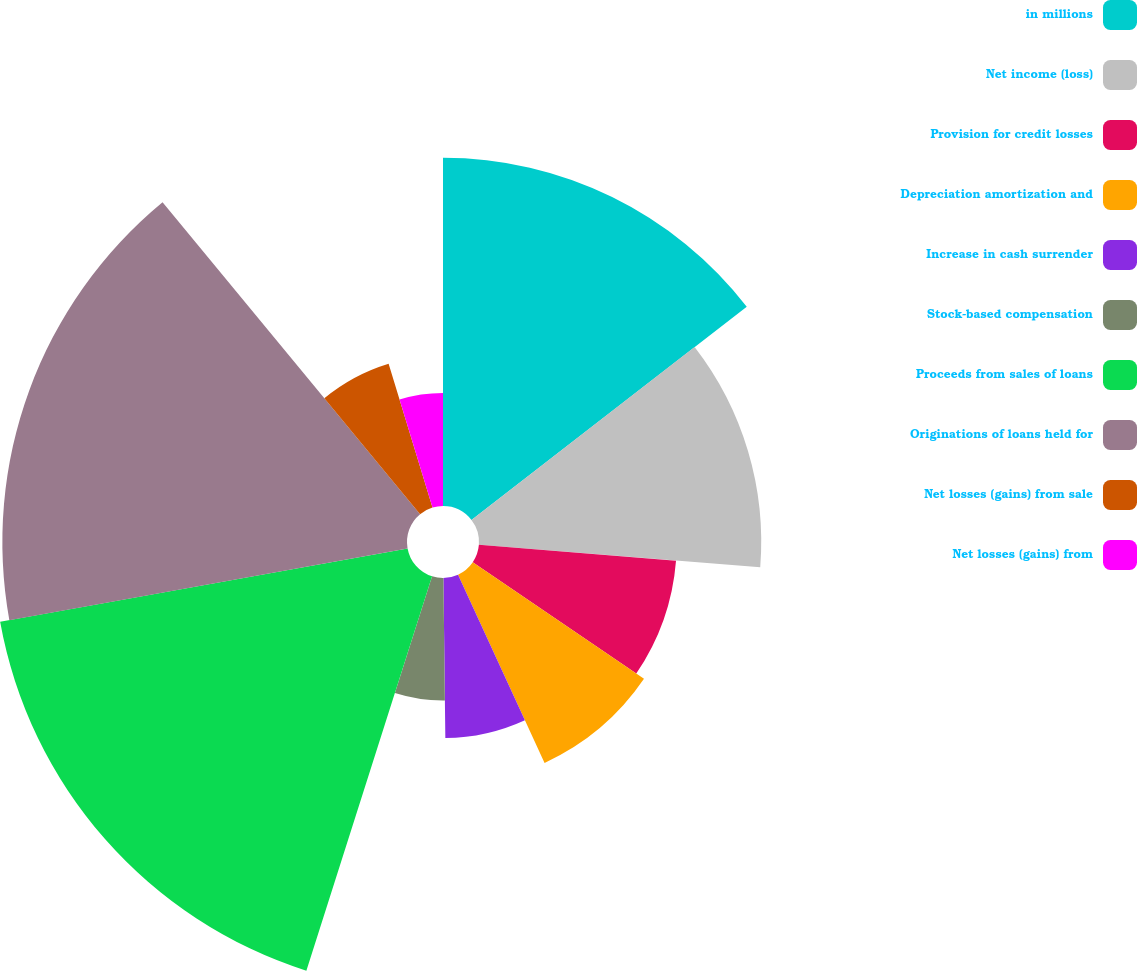Convert chart. <chart><loc_0><loc_0><loc_500><loc_500><pie_chart><fcel>in millions<fcel>Net income (loss)<fcel>Provision for credit losses<fcel>Depreciation amortization and<fcel>Increase in cash surrender<fcel>Stock-based compensation<fcel>Proceeds from sales of loans<fcel>Originations of loans held for<fcel>Net losses (gains) from sale<fcel>Net losses (gains) from<nl><fcel>14.51%<fcel>11.76%<fcel>8.24%<fcel>8.63%<fcel>6.67%<fcel>5.1%<fcel>17.25%<fcel>16.86%<fcel>6.27%<fcel>4.71%<nl></chart> 